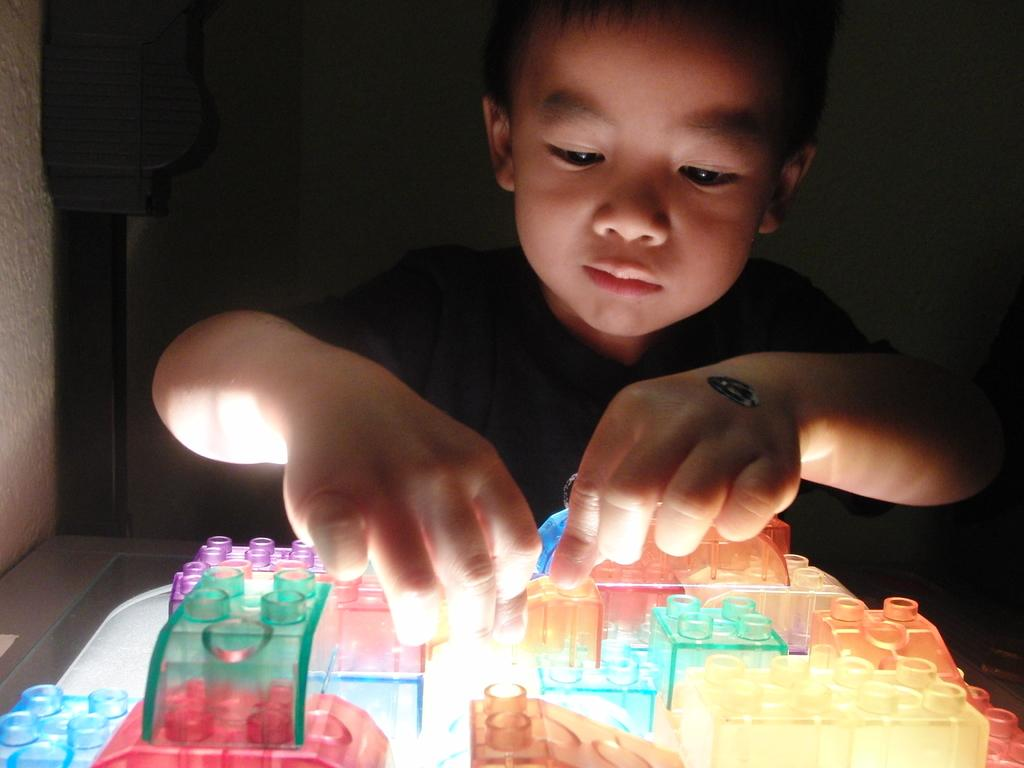Who is the main subject in the image? There is a boy in the image. What is the boy doing in the image? The boy is sitting and playing with toys. What can be observed about the background of the image? The background of the image is dark. What type of stove can be seen in the image? There is no stove present in the image. Does the boy have a tail in the image? The boy does not have a tail in the image, as humans do not have tails. 